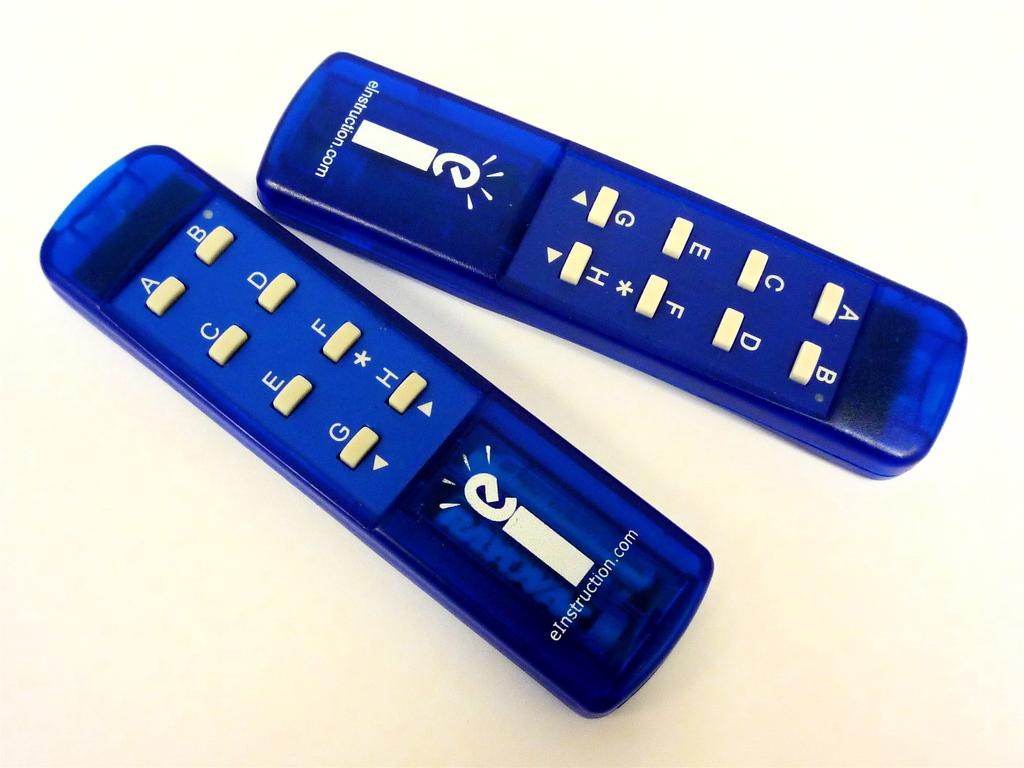What is the first letter on the clicker?
Provide a short and direct response. A. 